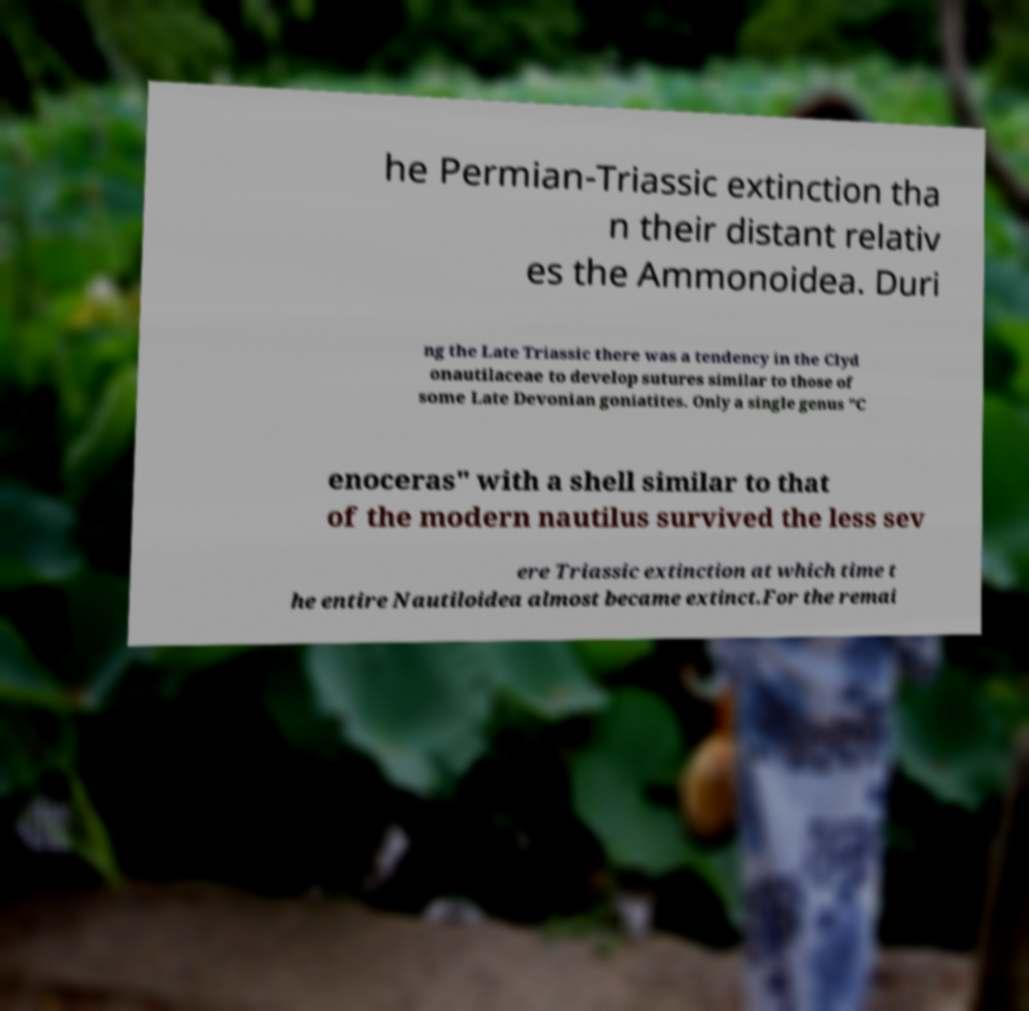Please read and relay the text visible in this image. What does it say? he Permian-Triassic extinction tha n their distant relativ es the Ammonoidea. Duri ng the Late Triassic there was a tendency in the Clyd onautilaceae to develop sutures similar to those of some Late Devonian goniatites. Only a single genus "C enoceras" with a shell similar to that of the modern nautilus survived the less sev ere Triassic extinction at which time t he entire Nautiloidea almost became extinct.For the remai 